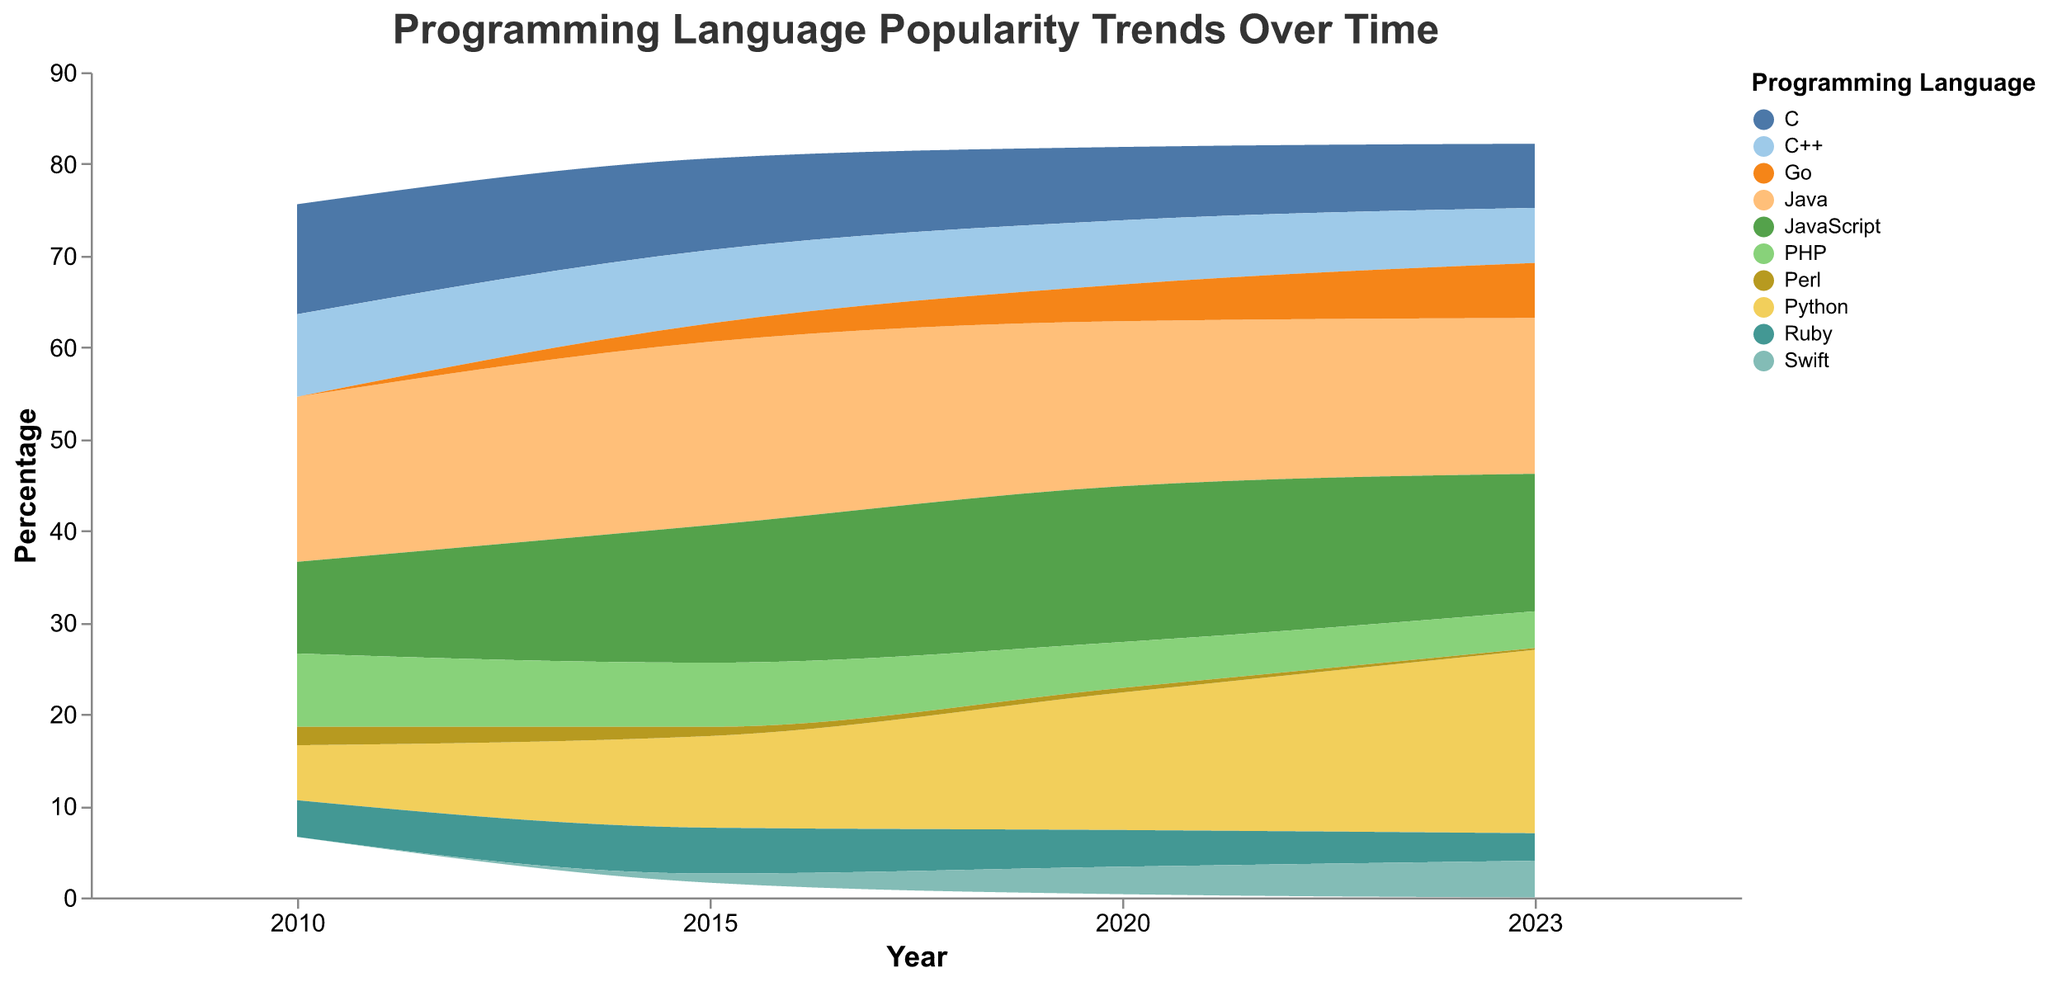What is the title of the figure? The title is usually located at the top of the figure and is used to describe what the figure represents. In this case, it says "Programming Language Popularity Trends Over Time".
Answer: Programming Language Popularity Trends Over Time Which programming language had the highest percentage in 2023? Look at the data for the year 2023 and find the language with the highest percentage. From the figure, it's clear that Python had the highest percentage.
Answer: Python How did the popularity of C change from 2010 to 2023? To answer this, check the stream for the C programming language across the years and note the change in its percentage from 2010 to 2023. The percentage decreased from 12% in 2010 to 7% in 2023.
Answer: Decreased from 12% to 7% Compare the popularity trends of Python and JavaScript from 2010 to 2023. Observe the streams for Python and JavaScript over the years. Python has shown a steady increase, from 6% in 2010 to 20% in 2023. JavaScript also increased but showed more fluctuation, peaking around 2020 then slightly decreasing.
Answer: Python increased steadily, JavaScript fluctuated but generally increased What was the overall trend for Perl from 2010 to 2023? Check the data stream for Perl. It started at 2% in 2010 and consistently decreased, reaching 0.2% by 2023.
Answer: Consistently decreased Which programming languages were primarily used by Web Developers in 2020? Look at the data for the year 2020 and identify the languages used by Web Developers: JavaScript, PHP, and Ruby.
Answer: JavaScript, PHP, Ruby Calculate the average percentage of Go from 2015 to 2023. Add up the percentage values for Go (2% in 2015, 4% in 2020, and 6% in 2023) and divide by the number of years. (2 + 4 + 6) / 3 = 4%.
Answer: 4% Compare the popularity of PHP in 2010 and 2023. Note the percentages for PHP in 2010 (8%) and 2023 (4%) and determine the change. The popularity decreased by 4%.
Answer: Decreased by 4% Which languages had a steady or increasing trend in their popularity from 2010 to 2023? Observe each language's stream from 2010 to 2023. Python, Go, and Swift all show a steady or increasing trend in popularity.
Answer: Python, Go, Swift What was the primary developer demographic for Swift in 2023? Look at the data for Swift in 2023. The primary developer demographic listed is "Mobile App Developers".
Answer: Mobile App Developers 